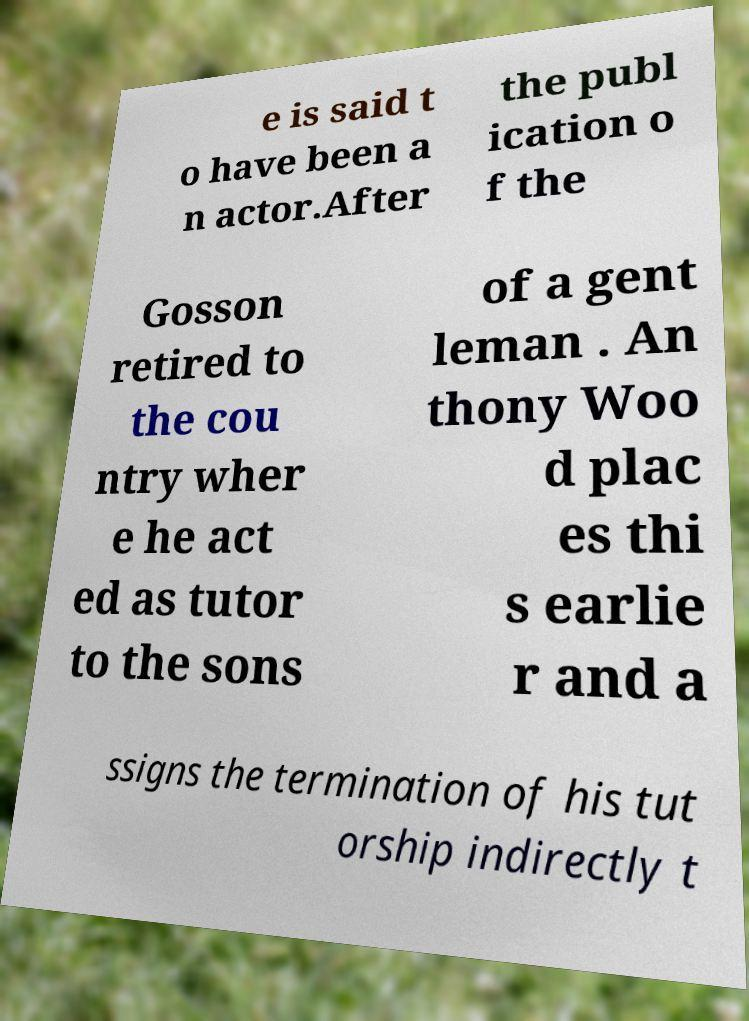Could you assist in decoding the text presented in this image and type it out clearly? e is said t o have been a n actor.After the publ ication o f the Gosson retired to the cou ntry wher e he act ed as tutor to the sons of a gent leman . An thony Woo d plac es thi s earlie r and a ssigns the termination of his tut orship indirectly t 